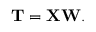<formula> <loc_0><loc_0><loc_500><loc_500>T = X W .</formula> 